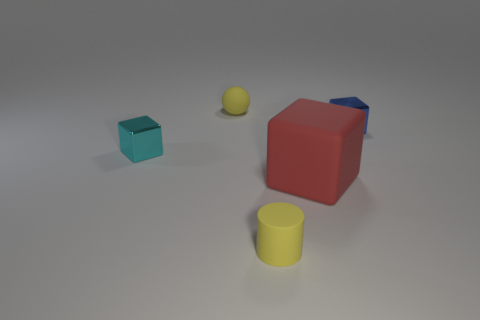The tiny metal cube on the right side of the tiny yellow cylinder is what color?
Offer a very short reply. Blue. There is a red object that is in front of the blue block; is it the same size as the tiny blue thing?
Give a very brief answer. No. What is the size of the red thing that is the same shape as the tiny cyan metallic object?
Give a very brief answer. Large. Is there any other thing that has the same size as the red cube?
Your response must be concise. No. Is the shape of the red matte object the same as the small blue metal object?
Keep it short and to the point. Yes. Are there fewer small cylinders behind the blue shiny object than large things left of the small yellow ball?
Provide a succinct answer. No. There is a small blue metallic cube; how many metallic blocks are to the left of it?
Make the answer very short. 1. Does the matte thing that is right of the yellow matte cylinder have the same shape as the tiny metallic object that is on the right side of the yellow rubber cylinder?
Ensure brevity in your answer.  Yes. How many other objects are the same color as the big matte object?
Ensure brevity in your answer.  0. What is the tiny cyan object left of the small yellow matte object in front of the tiny cyan thing that is in front of the tiny blue metal object made of?
Offer a very short reply. Metal. 